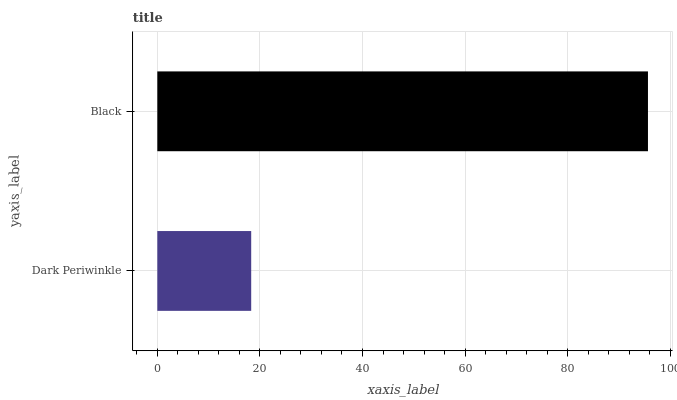Is Dark Periwinkle the minimum?
Answer yes or no. Yes. Is Black the maximum?
Answer yes or no. Yes. Is Black the minimum?
Answer yes or no. No. Is Black greater than Dark Periwinkle?
Answer yes or no. Yes. Is Dark Periwinkle less than Black?
Answer yes or no. Yes. Is Dark Periwinkle greater than Black?
Answer yes or no. No. Is Black less than Dark Periwinkle?
Answer yes or no. No. Is Black the high median?
Answer yes or no. Yes. Is Dark Periwinkle the low median?
Answer yes or no. Yes. Is Dark Periwinkle the high median?
Answer yes or no. No. Is Black the low median?
Answer yes or no. No. 